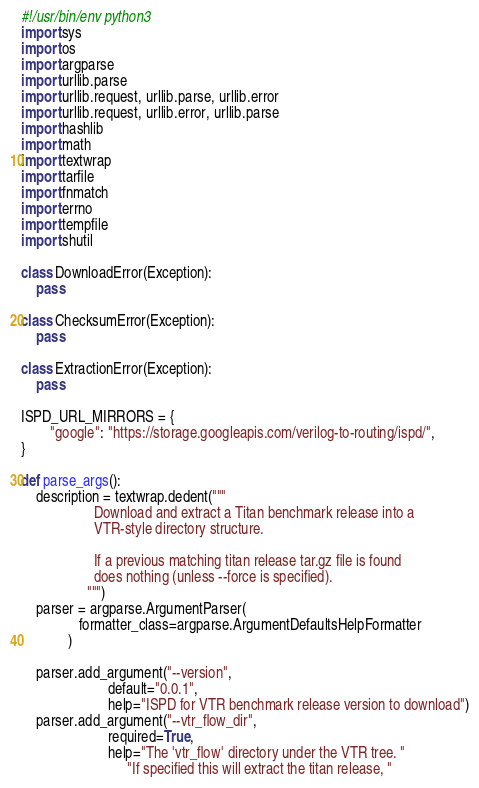Convert code to text. <code><loc_0><loc_0><loc_500><loc_500><_Python_>#!/usr/bin/env python3
import sys
import os
import argparse
import urllib.parse
import urllib.request, urllib.parse, urllib.error
import urllib.request, urllib.error, urllib.parse
import hashlib
import math
import textwrap
import tarfile
import fnmatch
import errno
import tempfile
import shutil

class DownloadError(Exception):
    pass

class ChecksumError(Exception):
    pass

class ExtractionError(Exception):
    pass

ISPD_URL_MIRRORS = {
        "google": "https://storage.googleapis.com/verilog-to-routing/ispd/",
}

def parse_args():
    description = textwrap.dedent("""
                    Download and extract a Titan benchmark release into a
                    VTR-style directory structure.

                    If a previous matching titan release tar.gz file is found
                    does nothing (unless --force is specified).
                  """)
    parser = argparse.ArgumentParser(
                formatter_class=argparse.ArgumentDefaultsHelpFormatter
             )

    parser.add_argument("--version",
                        default="0.0.1",
                        help="ISPD for VTR benchmark release version to download")
    parser.add_argument("--vtr_flow_dir",
                        required=True,
                        help="The 'vtr_flow' directory under the VTR tree. "
                             "If specified this will extract the titan release, "</code> 